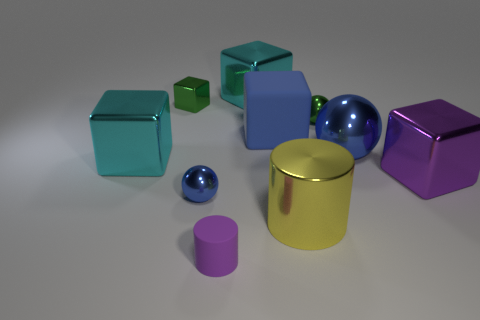Subtract all yellow balls. How many cyan blocks are left? 2 Subtract all matte blocks. How many blocks are left? 4 Subtract all balls. How many objects are left? 7 Subtract all blue balls. How many balls are left? 1 Subtract all blue matte blocks. Subtract all large yellow cylinders. How many objects are left? 8 Add 5 blue rubber objects. How many blue rubber objects are left? 6 Add 4 big matte cylinders. How many big matte cylinders exist? 4 Subtract 0 gray cylinders. How many objects are left? 10 Subtract all yellow cubes. Subtract all cyan cylinders. How many cubes are left? 5 